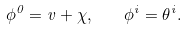Convert formula to latex. <formula><loc_0><loc_0><loc_500><loc_500>\phi ^ { 0 } = v + \chi , \quad \phi ^ { i } = \theta ^ { i } .</formula> 